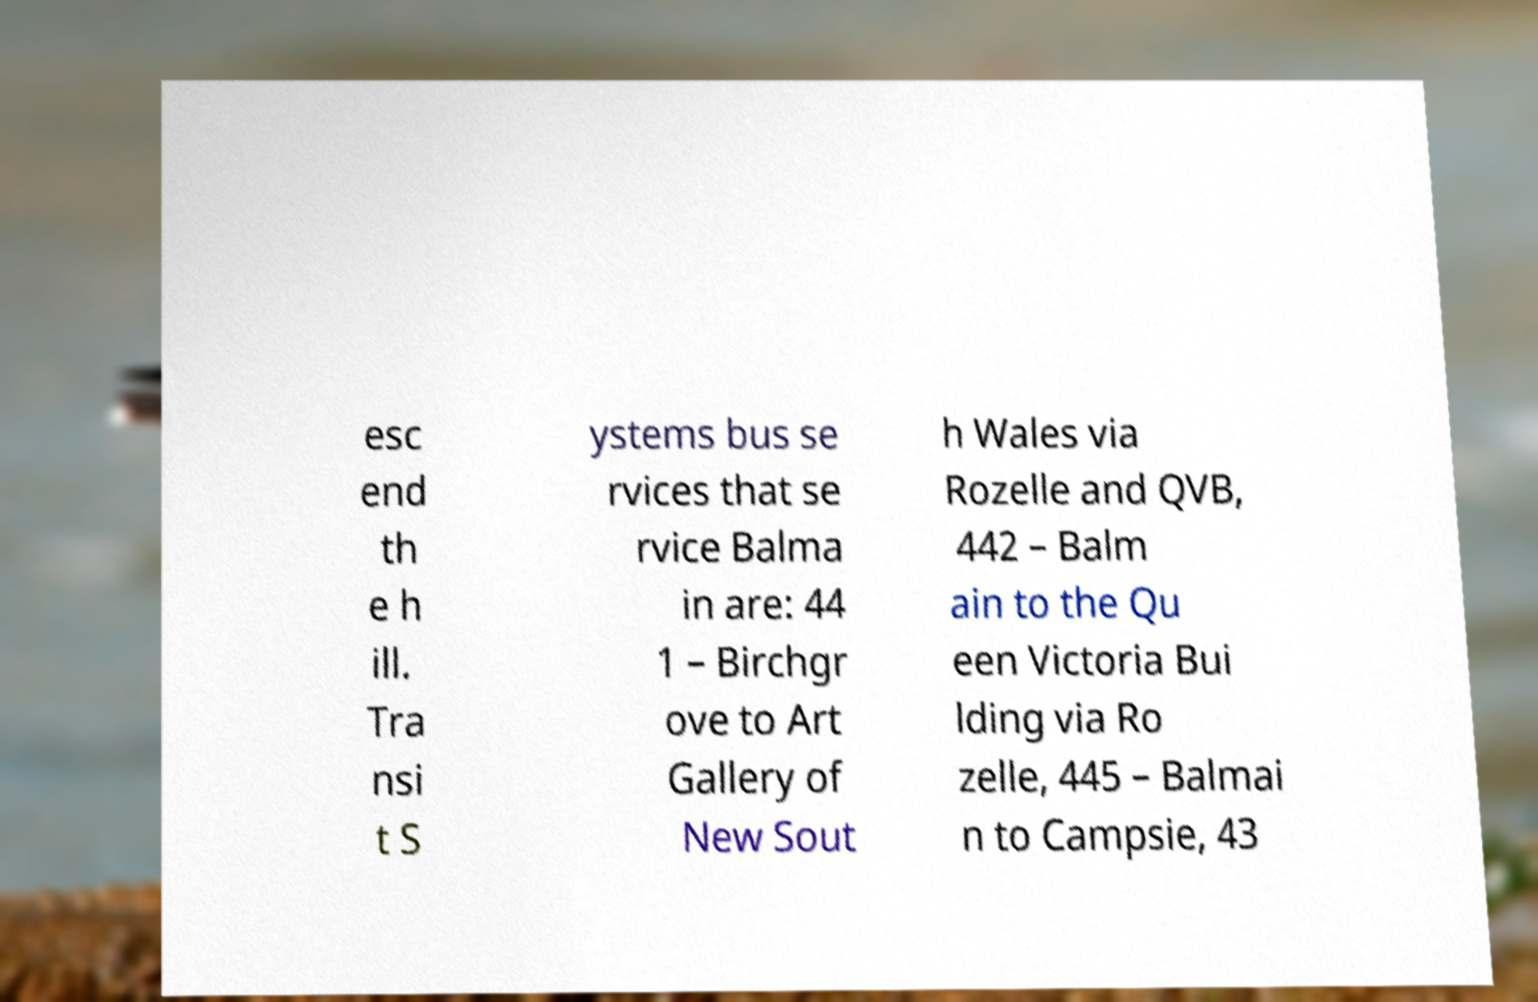There's text embedded in this image that I need extracted. Can you transcribe it verbatim? esc end th e h ill. Tra nsi t S ystems bus se rvices that se rvice Balma in are: 44 1 – Birchgr ove to Art Gallery of New Sout h Wales via Rozelle and QVB, 442 – Balm ain to the Qu een Victoria Bui lding via Ro zelle, 445 – Balmai n to Campsie, 43 